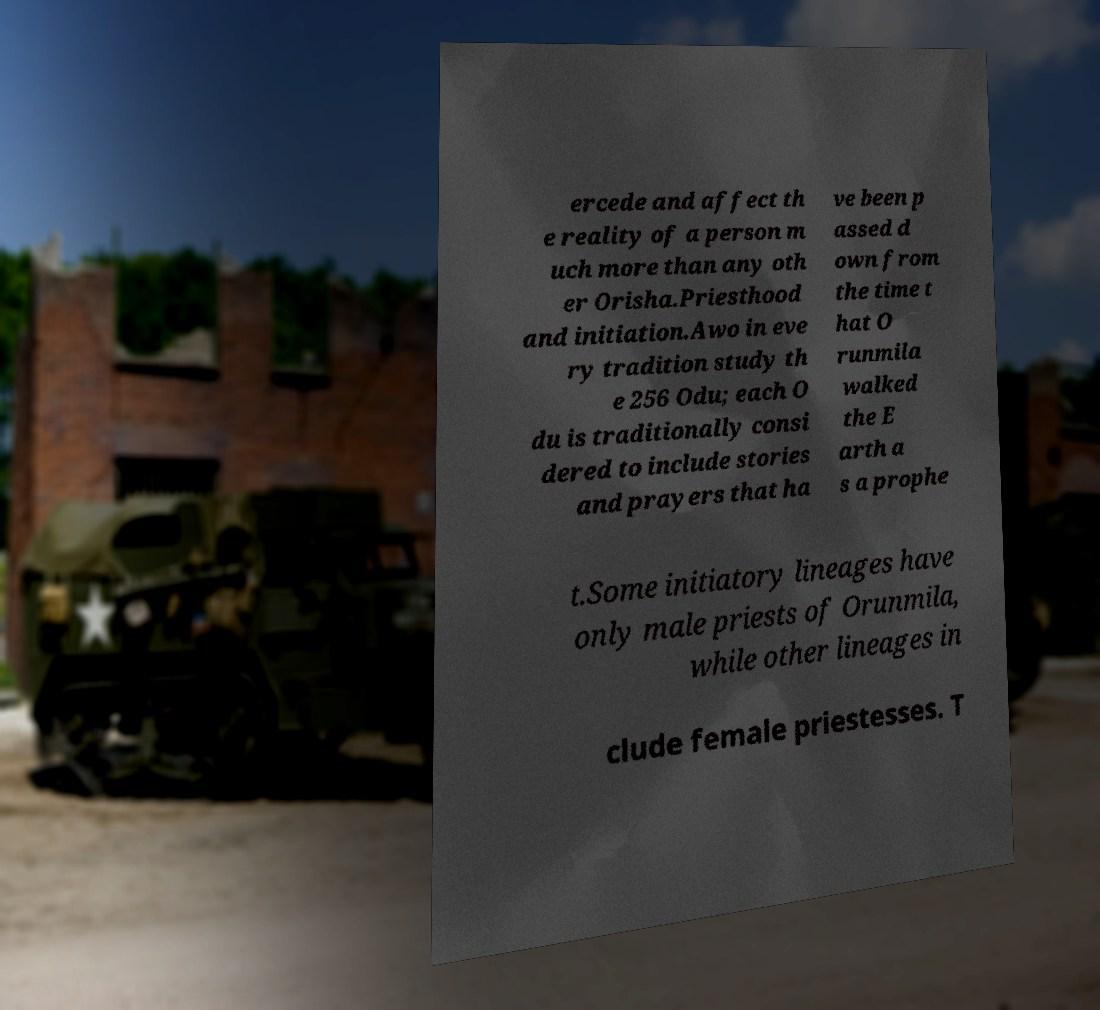Please identify and transcribe the text found in this image. ercede and affect th e reality of a person m uch more than any oth er Orisha.Priesthood and initiation.Awo in eve ry tradition study th e 256 Odu; each O du is traditionally consi dered to include stories and prayers that ha ve been p assed d own from the time t hat O runmila walked the E arth a s a prophe t.Some initiatory lineages have only male priests of Orunmila, while other lineages in clude female priestesses. T 